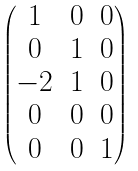<formula> <loc_0><loc_0><loc_500><loc_500>\begin{pmatrix} 1 & 0 & 0 \\ 0 & 1 & 0 \\ - 2 & 1 & 0 \\ 0 & 0 & 0 \\ 0 & 0 & 1 \end{pmatrix}</formula> 